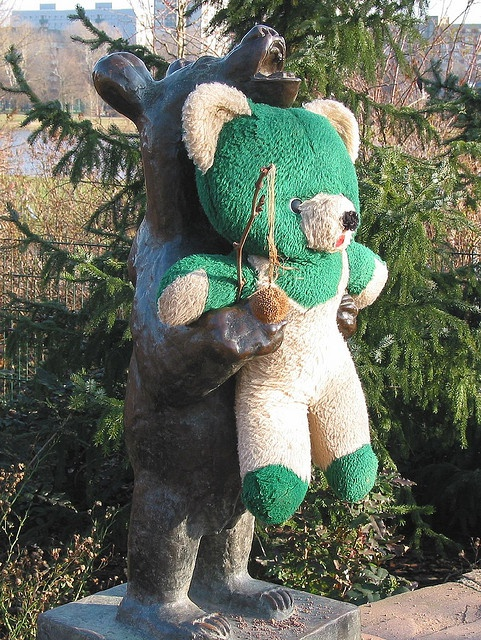Describe the objects in this image and their specific colors. I can see a teddy bear in ivory, turquoise, and black tones in this image. 